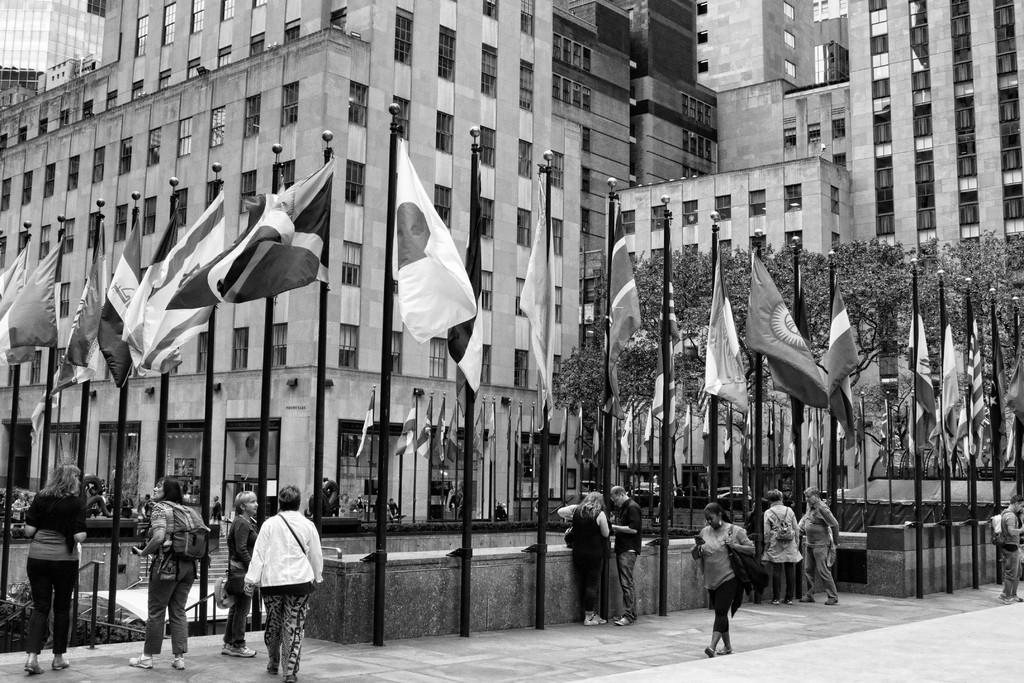What type of structures can be seen in the image? There are buildings in the image. What other natural elements are present in the image? There are trees in the image. What are the people in the image doing? Some people are walking, and others are standing in the image. What decorative elements can be seen in the image? There are flags on poles in the image. What are some people carrying in the image? Some people are wearing bags in the image. Can you see a giraffe walking among the people in the image? No, there is no giraffe present in the image. Is there a water fountain in the image where people can drink? There is no water fountain mentioned in the image, only flags on poles. 